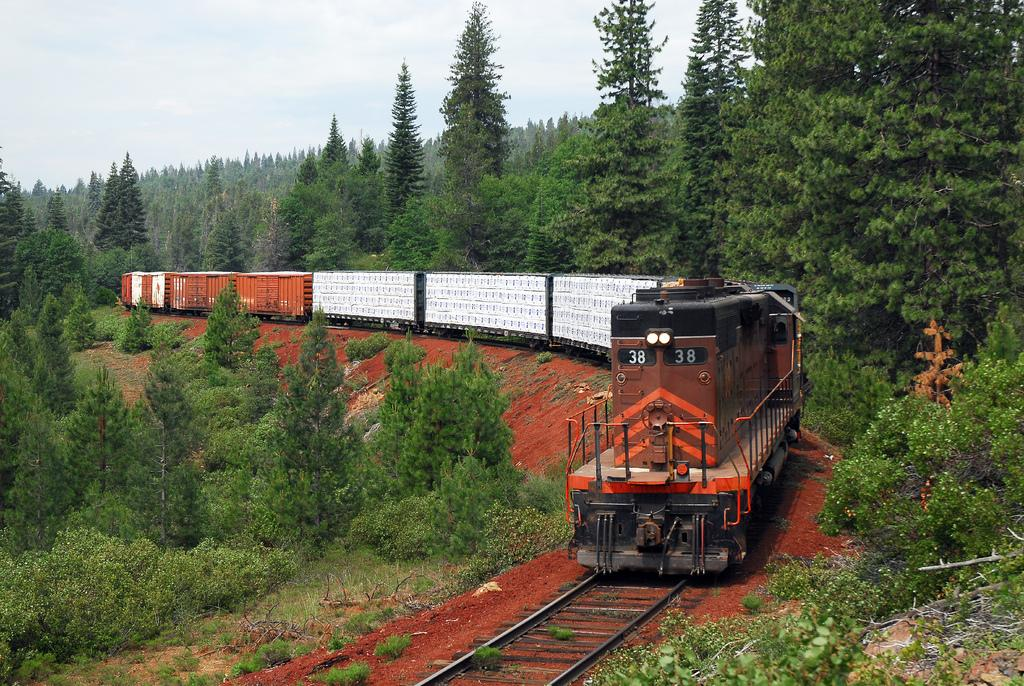What is located on the right side of the image? There is a train on the right side of the image. What type of vegetation can be seen on both sides of the image? There is greenery on both sides of the image. What is visible at the top of the image? The sky is visible at the top of the image. How many locks can be seen securing the sheep in the image? There are no sheep or locks present in the image. 